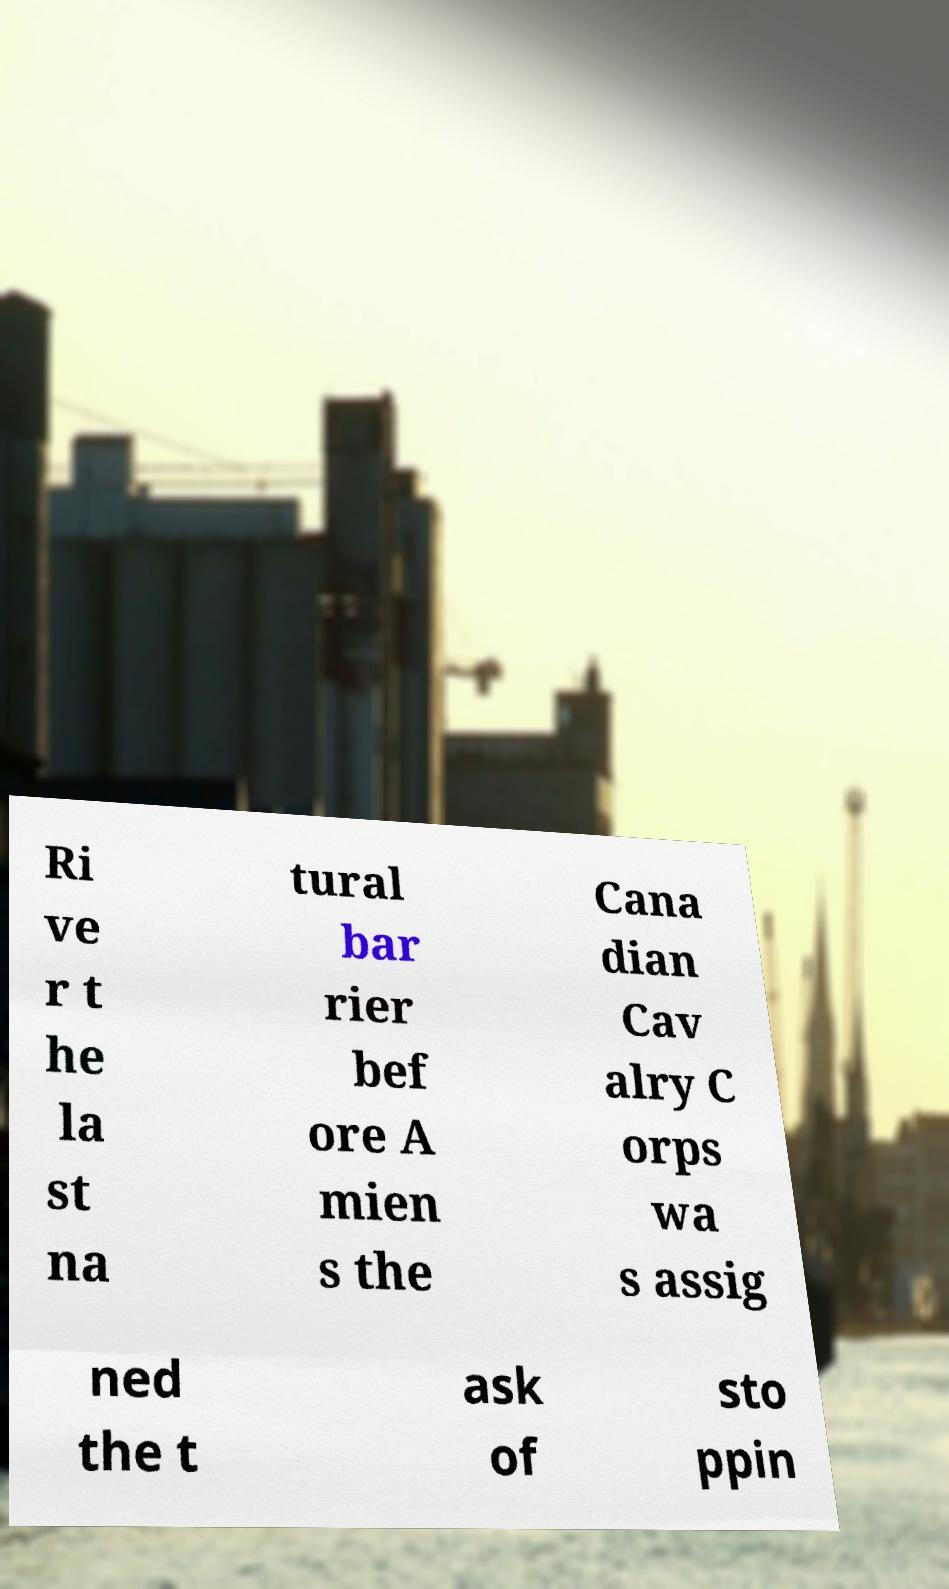What messages or text are displayed in this image? I need them in a readable, typed format. Ri ve r t he la st na tural bar rier bef ore A mien s the Cana dian Cav alry C orps wa s assig ned the t ask of sto ppin 